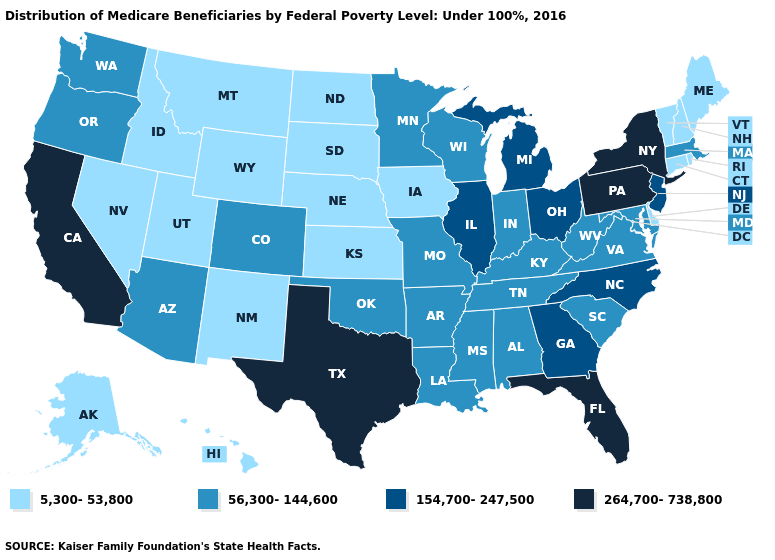Name the states that have a value in the range 154,700-247,500?
Give a very brief answer. Georgia, Illinois, Michigan, New Jersey, North Carolina, Ohio. Name the states that have a value in the range 5,300-53,800?
Give a very brief answer. Alaska, Connecticut, Delaware, Hawaii, Idaho, Iowa, Kansas, Maine, Montana, Nebraska, Nevada, New Hampshire, New Mexico, North Dakota, Rhode Island, South Dakota, Utah, Vermont, Wyoming. How many symbols are there in the legend?
Give a very brief answer. 4. Name the states that have a value in the range 56,300-144,600?
Quick response, please. Alabama, Arizona, Arkansas, Colorado, Indiana, Kentucky, Louisiana, Maryland, Massachusetts, Minnesota, Mississippi, Missouri, Oklahoma, Oregon, South Carolina, Tennessee, Virginia, Washington, West Virginia, Wisconsin. What is the value of Florida?
Concise answer only. 264,700-738,800. What is the lowest value in the USA?
Write a very short answer. 5,300-53,800. Does Oregon have the highest value in the West?
Concise answer only. No. What is the value of Colorado?
Write a very short answer. 56,300-144,600. What is the value of New Mexico?
Short answer required. 5,300-53,800. Which states hav the highest value in the West?
Write a very short answer. California. Does Rhode Island have the lowest value in the USA?
Quick response, please. Yes. Name the states that have a value in the range 154,700-247,500?
Concise answer only. Georgia, Illinois, Michigan, New Jersey, North Carolina, Ohio. Does Colorado have the lowest value in the West?
Answer briefly. No. 